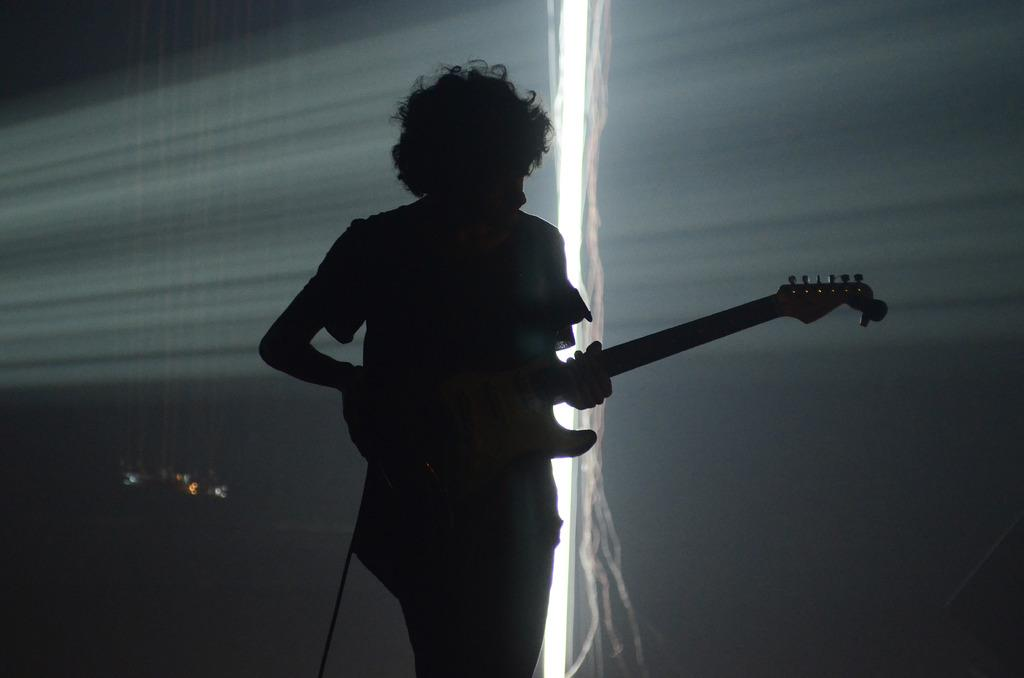What is the main subject in the foreground of the image? There is a man standing in the foreground of the image. What is the man holding in the image? The man is holding a guitar. What can be seen in the background of the image? There appears to be a screen in the background of the image. What type of basket is visible on the man's head in the image? There is no basket visible on the man's head in the image. How many rays can be seen emanating from the guitar in the image? There are no rays emanating from the guitar in the image. 